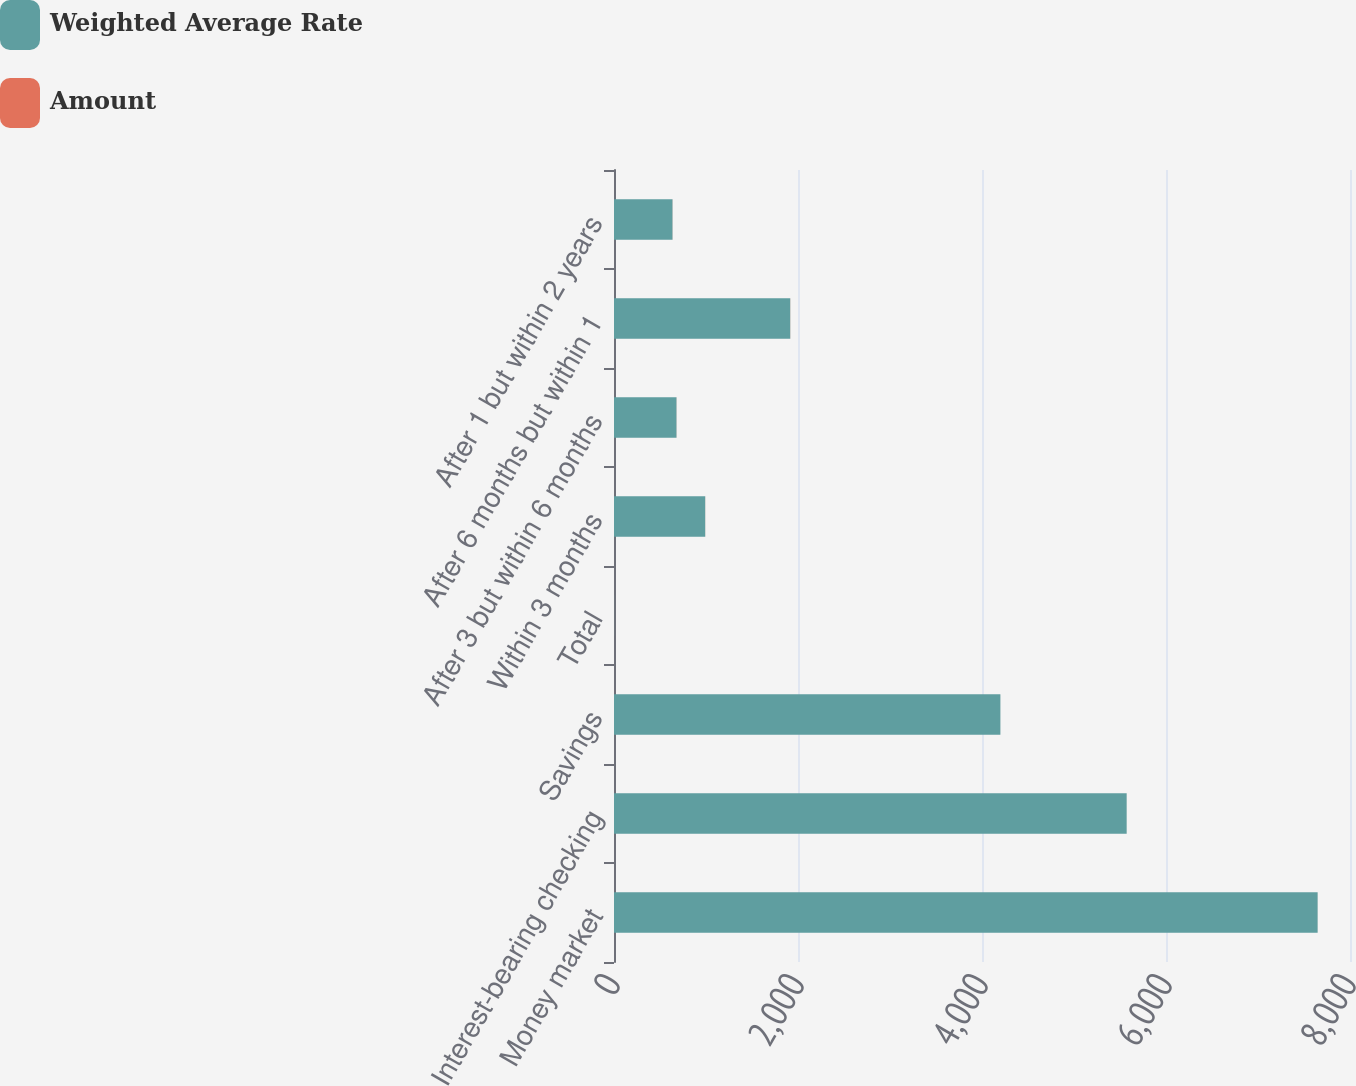Convert chart to OTSL. <chart><loc_0><loc_0><loc_500><loc_500><stacked_bar_chart><ecel><fcel>Money market<fcel>Interest-bearing checking<fcel>Savings<fcel>Total<fcel>Within 3 months<fcel>After 3 but within 6 months<fcel>After 6 months but within 1<fcel>After 1 but within 2 years<nl><fcel>Weighted Average Rate<fcel>7648.3<fcel>5572.5<fcel>4199.9<fcel>1.1<fcel>991.5<fcel>679.6<fcel>1915.6<fcel>636.1<nl><fcel>Amount<fcel>0.29<fcel>0.16<fcel>0.13<fcel>0.21<fcel>0.69<fcel>0.86<fcel>1.1<fcel>1.06<nl></chart> 